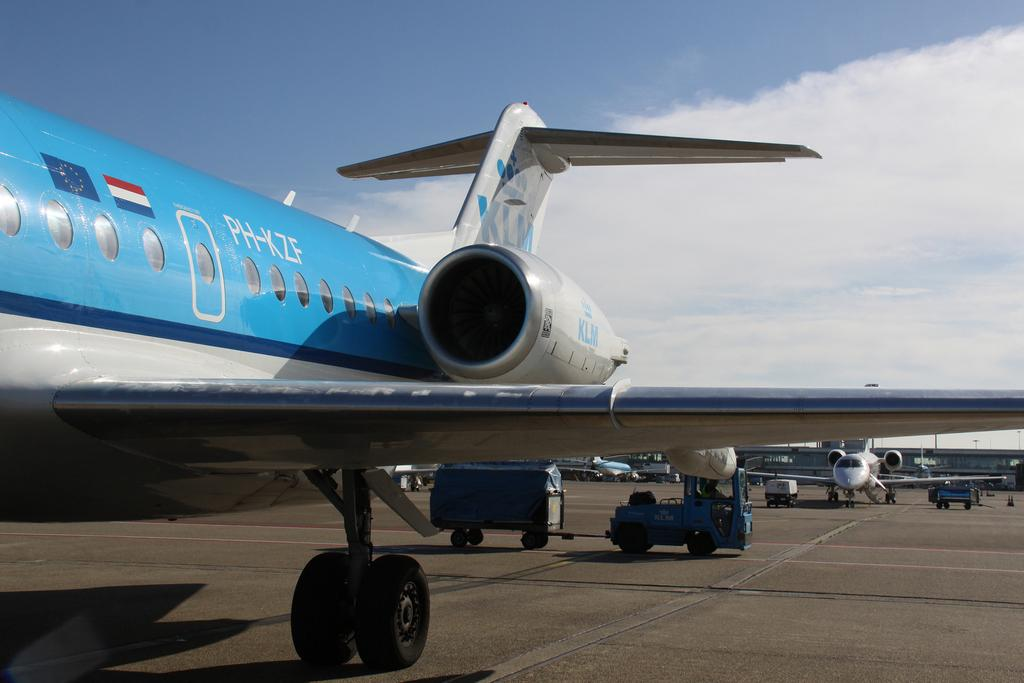<image>
Write a terse but informative summary of the picture. A jet plane with the letters PH-ZKF written on it 